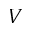Convert formula to latex. <formula><loc_0><loc_0><loc_500><loc_500>V</formula> 